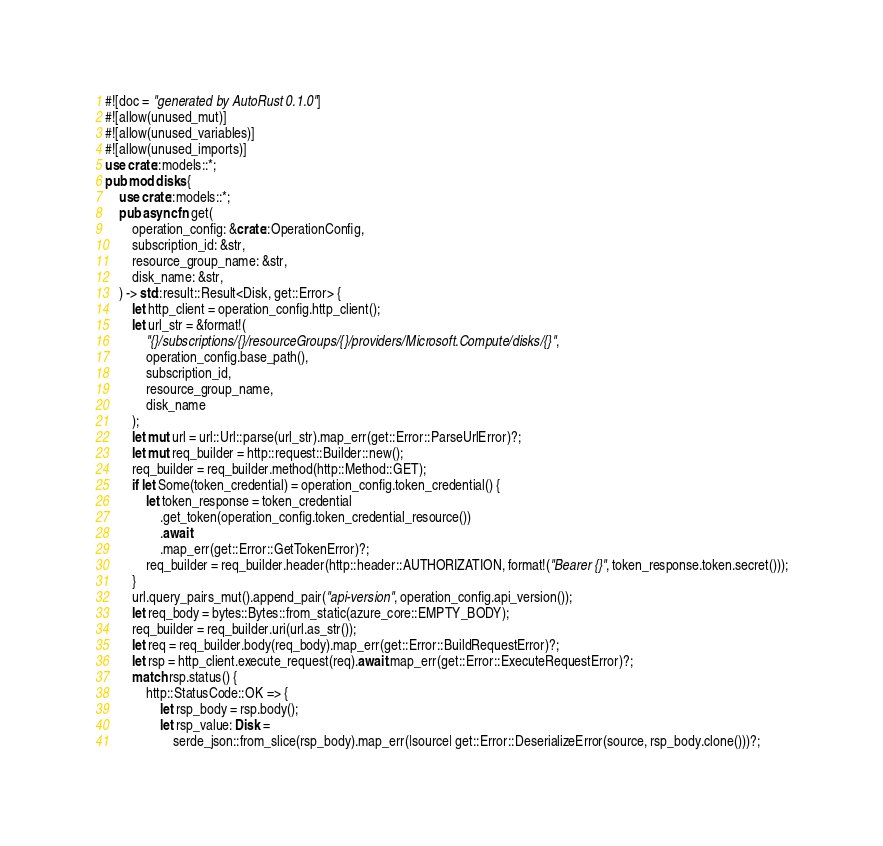<code> <loc_0><loc_0><loc_500><loc_500><_Rust_>#![doc = "generated by AutoRust 0.1.0"]
#![allow(unused_mut)]
#![allow(unused_variables)]
#![allow(unused_imports)]
use crate::models::*;
pub mod disks {
    use crate::models::*;
    pub async fn get(
        operation_config: &crate::OperationConfig,
        subscription_id: &str,
        resource_group_name: &str,
        disk_name: &str,
    ) -> std::result::Result<Disk, get::Error> {
        let http_client = operation_config.http_client();
        let url_str = &format!(
            "{}/subscriptions/{}/resourceGroups/{}/providers/Microsoft.Compute/disks/{}",
            operation_config.base_path(),
            subscription_id,
            resource_group_name,
            disk_name
        );
        let mut url = url::Url::parse(url_str).map_err(get::Error::ParseUrlError)?;
        let mut req_builder = http::request::Builder::new();
        req_builder = req_builder.method(http::Method::GET);
        if let Some(token_credential) = operation_config.token_credential() {
            let token_response = token_credential
                .get_token(operation_config.token_credential_resource())
                .await
                .map_err(get::Error::GetTokenError)?;
            req_builder = req_builder.header(http::header::AUTHORIZATION, format!("Bearer {}", token_response.token.secret()));
        }
        url.query_pairs_mut().append_pair("api-version", operation_config.api_version());
        let req_body = bytes::Bytes::from_static(azure_core::EMPTY_BODY);
        req_builder = req_builder.uri(url.as_str());
        let req = req_builder.body(req_body).map_err(get::Error::BuildRequestError)?;
        let rsp = http_client.execute_request(req).await.map_err(get::Error::ExecuteRequestError)?;
        match rsp.status() {
            http::StatusCode::OK => {
                let rsp_body = rsp.body();
                let rsp_value: Disk =
                    serde_json::from_slice(rsp_body).map_err(|source| get::Error::DeserializeError(source, rsp_body.clone()))?;</code> 